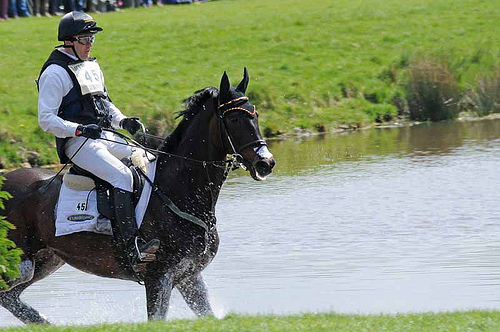Which type of animal is this, a horse or a goat? The animal in the picture is a horse. 